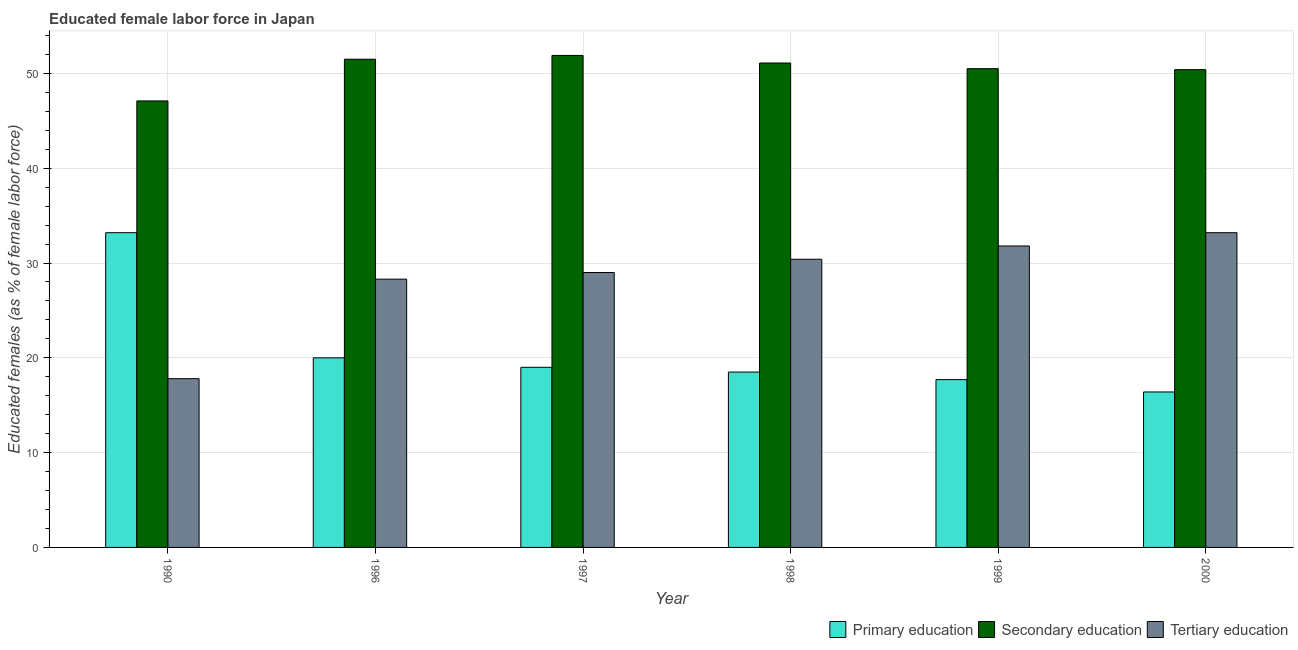How many different coloured bars are there?
Make the answer very short. 3. How many groups of bars are there?
Offer a very short reply. 6. Are the number of bars per tick equal to the number of legend labels?
Your answer should be compact. Yes. Are the number of bars on each tick of the X-axis equal?
Your answer should be very brief. Yes. How many bars are there on the 3rd tick from the right?
Your answer should be very brief. 3. What is the label of the 3rd group of bars from the left?
Give a very brief answer. 1997. What is the percentage of female labor force who received secondary education in 2000?
Your response must be concise. 50.4. Across all years, what is the maximum percentage of female labor force who received primary education?
Ensure brevity in your answer.  33.2. Across all years, what is the minimum percentage of female labor force who received tertiary education?
Keep it short and to the point. 17.8. In which year was the percentage of female labor force who received primary education minimum?
Provide a short and direct response. 2000. What is the total percentage of female labor force who received tertiary education in the graph?
Make the answer very short. 170.5. What is the difference between the percentage of female labor force who received secondary education in 1999 and that in 2000?
Your answer should be very brief. 0.1. What is the difference between the percentage of female labor force who received tertiary education in 2000 and the percentage of female labor force who received secondary education in 1996?
Offer a terse response. 4.9. What is the average percentage of female labor force who received tertiary education per year?
Your answer should be compact. 28.42. In how many years, is the percentage of female labor force who received tertiary education greater than 22 %?
Your answer should be very brief. 5. What is the ratio of the percentage of female labor force who received primary education in 1990 to that in 1996?
Offer a terse response. 1.66. Is the difference between the percentage of female labor force who received tertiary education in 1990 and 1996 greater than the difference between the percentage of female labor force who received primary education in 1990 and 1996?
Provide a succinct answer. No. What is the difference between the highest and the second highest percentage of female labor force who received tertiary education?
Make the answer very short. 1.4. What is the difference between the highest and the lowest percentage of female labor force who received secondary education?
Make the answer very short. 4.8. What does the 3rd bar from the right in 1996 represents?
Provide a short and direct response. Primary education. How many bars are there?
Provide a succinct answer. 18. How many years are there in the graph?
Offer a terse response. 6. Are the values on the major ticks of Y-axis written in scientific E-notation?
Keep it short and to the point. No. Does the graph contain any zero values?
Offer a terse response. No. How are the legend labels stacked?
Keep it short and to the point. Horizontal. What is the title of the graph?
Keep it short and to the point. Educated female labor force in Japan. What is the label or title of the X-axis?
Offer a terse response. Year. What is the label or title of the Y-axis?
Provide a succinct answer. Educated females (as % of female labor force). What is the Educated females (as % of female labor force) of Primary education in 1990?
Make the answer very short. 33.2. What is the Educated females (as % of female labor force) of Secondary education in 1990?
Offer a terse response. 47.1. What is the Educated females (as % of female labor force) of Tertiary education in 1990?
Your response must be concise. 17.8. What is the Educated females (as % of female labor force) in Primary education in 1996?
Ensure brevity in your answer.  20. What is the Educated females (as % of female labor force) in Secondary education in 1996?
Your answer should be compact. 51.5. What is the Educated females (as % of female labor force) in Tertiary education in 1996?
Provide a short and direct response. 28.3. What is the Educated females (as % of female labor force) of Secondary education in 1997?
Offer a very short reply. 51.9. What is the Educated females (as % of female labor force) of Tertiary education in 1997?
Offer a very short reply. 29. What is the Educated females (as % of female labor force) of Secondary education in 1998?
Offer a terse response. 51.1. What is the Educated females (as % of female labor force) of Tertiary education in 1998?
Your answer should be very brief. 30.4. What is the Educated females (as % of female labor force) of Primary education in 1999?
Offer a terse response. 17.7. What is the Educated females (as % of female labor force) in Secondary education in 1999?
Provide a succinct answer. 50.5. What is the Educated females (as % of female labor force) in Tertiary education in 1999?
Your answer should be very brief. 31.8. What is the Educated females (as % of female labor force) in Primary education in 2000?
Make the answer very short. 16.4. What is the Educated females (as % of female labor force) in Secondary education in 2000?
Keep it short and to the point. 50.4. What is the Educated females (as % of female labor force) of Tertiary education in 2000?
Keep it short and to the point. 33.2. Across all years, what is the maximum Educated females (as % of female labor force) of Primary education?
Offer a terse response. 33.2. Across all years, what is the maximum Educated females (as % of female labor force) of Secondary education?
Offer a very short reply. 51.9. Across all years, what is the maximum Educated females (as % of female labor force) in Tertiary education?
Provide a succinct answer. 33.2. Across all years, what is the minimum Educated females (as % of female labor force) of Primary education?
Offer a very short reply. 16.4. Across all years, what is the minimum Educated females (as % of female labor force) in Secondary education?
Provide a short and direct response. 47.1. Across all years, what is the minimum Educated females (as % of female labor force) of Tertiary education?
Make the answer very short. 17.8. What is the total Educated females (as % of female labor force) in Primary education in the graph?
Offer a very short reply. 124.8. What is the total Educated females (as % of female labor force) of Secondary education in the graph?
Your answer should be compact. 302.5. What is the total Educated females (as % of female labor force) of Tertiary education in the graph?
Give a very brief answer. 170.5. What is the difference between the Educated females (as % of female labor force) in Tertiary education in 1990 and that in 1996?
Provide a short and direct response. -10.5. What is the difference between the Educated females (as % of female labor force) of Secondary education in 1990 and that in 1997?
Make the answer very short. -4.8. What is the difference between the Educated females (as % of female labor force) of Tertiary education in 1990 and that in 1997?
Keep it short and to the point. -11.2. What is the difference between the Educated females (as % of female labor force) of Tertiary education in 1990 and that in 1998?
Your answer should be compact. -12.6. What is the difference between the Educated females (as % of female labor force) of Primary education in 1990 and that in 1999?
Your response must be concise. 15.5. What is the difference between the Educated females (as % of female labor force) of Tertiary education in 1990 and that in 1999?
Make the answer very short. -14. What is the difference between the Educated females (as % of female labor force) of Secondary education in 1990 and that in 2000?
Keep it short and to the point. -3.3. What is the difference between the Educated females (as % of female labor force) in Tertiary education in 1990 and that in 2000?
Give a very brief answer. -15.4. What is the difference between the Educated females (as % of female labor force) of Primary education in 1996 and that in 1997?
Provide a succinct answer. 1. What is the difference between the Educated females (as % of female labor force) in Secondary education in 1996 and that in 1997?
Provide a succinct answer. -0.4. What is the difference between the Educated females (as % of female labor force) in Tertiary education in 1996 and that in 1997?
Give a very brief answer. -0.7. What is the difference between the Educated females (as % of female labor force) in Primary education in 1996 and that in 1998?
Ensure brevity in your answer.  1.5. What is the difference between the Educated females (as % of female labor force) in Primary education in 1996 and that in 1999?
Ensure brevity in your answer.  2.3. What is the difference between the Educated females (as % of female labor force) of Secondary education in 1996 and that in 1999?
Give a very brief answer. 1. What is the difference between the Educated females (as % of female labor force) in Tertiary education in 1996 and that in 1999?
Keep it short and to the point. -3.5. What is the difference between the Educated females (as % of female labor force) in Primary education in 1997 and that in 1998?
Make the answer very short. 0.5. What is the difference between the Educated females (as % of female labor force) in Secondary education in 1997 and that in 1998?
Offer a very short reply. 0.8. What is the difference between the Educated females (as % of female labor force) of Primary education in 1997 and that in 1999?
Ensure brevity in your answer.  1.3. What is the difference between the Educated females (as % of female labor force) of Secondary education in 1997 and that in 1999?
Your response must be concise. 1.4. What is the difference between the Educated females (as % of female labor force) in Tertiary education in 1997 and that in 1999?
Your answer should be compact. -2.8. What is the difference between the Educated females (as % of female labor force) of Secondary education in 1997 and that in 2000?
Make the answer very short. 1.5. What is the difference between the Educated females (as % of female labor force) of Tertiary education in 1997 and that in 2000?
Keep it short and to the point. -4.2. What is the difference between the Educated females (as % of female labor force) in Secondary education in 1998 and that in 1999?
Your answer should be compact. 0.6. What is the difference between the Educated females (as % of female labor force) of Tertiary education in 1998 and that in 1999?
Provide a succinct answer. -1.4. What is the difference between the Educated females (as % of female labor force) of Primary education in 1998 and that in 2000?
Ensure brevity in your answer.  2.1. What is the difference between the Educated females (as % of female labor force) in Secondary education in 1998 and that in 2000?
Your response must be concise. 0.7. What is the difference between the Educated females (as % of female labor force) in Secondary education in 1999 and that in 2000?
Make the answer very short. 0.1. What is the difference between the Educated females (as % of female labor force) of Primary education in 1990 and the Educated females (as % of female labor force) of Secondary education in 1996?
Offer a terse response. -18.3. What is the difference between the Educated females (as % of female labor force) of Primary education in 1990 and the Educated females (as % of female labor force) of Secondary education in 1997?
Give a very brief answer. -18.7. What is the difference between the Educated females (as % of female labor force) in Secondary education in 1990 and the Educated females (as % of female labor force) in Tertiary education in 1997?
Your answer should be compact. 18.1. What is the difference between the Educated females (as % of female labor force) in Primary education in 1990 and the Educated females (as % of female labor force) in Secondary education in 1998?
Provide a short and direct response. -17.9. What is the difference between the Educated females (as % of female labor force) in Primary education in 1990 and the Educated females (as % of female labor force) in Secondary education in 1999?
Make the answer very short. -17.3. What is the difference between the Educated females (as % of female labor force) in Primary education in 1990 and the Educated females (as % of female labor force) in Tertiary education in 1999?
Provide a short and direct response. 1.4. What is the difference between the Educated females (as % of female labor force) of Primary education in 1990 and the Educated females (as % of female labor force) of Secondary education in 2000?
Your answer should be compact. -17.2. What is the difference between the Educated females (as % of female labor force) of Primary education in 1996 and the Educated females (as % of female labor force) of Secondary education in 1997?
Offer a terse response. -31.9. What is the difference between the Educated females (as % of female labor force) in Primary education in 1996 and the Educated females (as % of female labor force) in Tertiary education in 1997?
Keep it short and to the point. -9. What is the difference between the Educated females (as % of female labor force) of Primary education in 1996 and the Educated females (as % of female labor force) of Secondary education in 1998?
Your answer should be compact. -31.1. What is the difference between the Educated females (as % of female labor force) of Primary education in 1996 and the Educated females (as % of female labor force) of Tertiary education in 1998?
Your answer should be compact. -10.4. What is the difference between the Educated females (as % of female labor force) in Secondary education in 1996 and the Educated females (as % of female labor force) in Tertiary education in 1998?
Provide a short and direct response. 21.1. What is the difference between the Educated females (as % of female labor force) of Primary education in 1996 and the Educated females (as % of female labor force) of Secondary education in 1999?
Offer a very short reply. -30.5. What is the difference between the Educated females (as % of female labor force) in Primary education in 1996 and the Educated females (as % of female labor force) in Tertiary education in 1999?
Provide a succinct answer. -11.8. What is the difference between the Educated females (as % of female labor force) in Secondary education in 1996 and the Educated females (as % of female labor force) in Tertiary education in 1999?
Provide a short and direct response. 19.7. What is the difference between the Educated females (as % of female labor force) in Primary education in 1996 and the Educated females (as % of female labor force) in Secondary education in 2000?
Your answer should be compact. -30.4. What is the difference between the Educated females (as % of female labor force) in Primary education in 1997 and the Educated females (as % of female labor force) in Secondary education in 1998?
Ensure brevity in your answer.  -32.1. What is the difference between the Educated females (as % of female labor force) of Primary education in 1997 and the Educated females (as % of female labor force) of Tertiary education in 1998?
Your answer should be very brief. -11.4. What is the difference between the Educated females (as % of female labor force) of Primary education in 1997 and the Educated females (as % of female labor force) of Secondary education in 1999?
Offer a very short reply. -31.5. What is the difference between the Educated females (as % of female labor force) in Primary education in 1997 and the Educated females (as % of female labor force) in Tertiary education in 1999?
Provide a short and direct response. -12.8. What is the difference between the Educated females (as % of female labor force) in Secondary education in 1997 and the Educated females (as % of female labor force) in Tertiary education in 1999?
Your response must be concise. 20.1. What is the difference between the Educated females (as % of female labor force) in Primary education in 1997 and the Educated females (as % of female labor force) in Secondary education in 2000?
Your answer should be very brief. -31.4. What is the difference between the Educated females (as % of female labor force) in Primary education in 1998 and the Educated females (as % of female labor force) in Secondary education in 1999?
Keep it short and to the point. -32. What is the difference between the Educated females (as % of female labor force) in Primary education in 1998 and the Educated females (as % of female labor force) in Tertiary education in 1999?
Your answer should be very brief. -13.3. What is the difference between the Educated females (as % of female labor force) in Secondary education in 1998 and the Educated females (as % of female labor force) in Tertiary education in 1999?
Keep it short and to the point. 19.3. What is the difference between the Educated females (as % of female labor force) of Primary education in 1998 and the Educated females (as % of female labor force) of Secondary education in 2000?
Your answer should be very brief. -31.9. What is the difference between the Educated females (as % of female labor force) of Primary education in 1998 and the Educated females (as % of female labor force) of Tertiary education in 2000?
Provide a short and direct response. -14.7. What is the difference between the Educated females (as % of female labor force) of Secondary education in 1998 and the Educated females (as % of female labor force) of Tertiary education in 2000?
Offer a terse response. 17.9. What is the difference between the Educated females (as % of female labor force) in Primary education in 1999 and the Educated females (as % of female labor force) in Secondary education in 2000?
Keep it short and to the point. -32.7. What is the difference between the Educated females (as % of female labor force) of Primary education in 1999 and the Educated females (as % of female labor force) of Tertiary education in 2000?
Ensure brevity in your answer.  -15.5. What is the average Educated females (as % of female labor force) of Primary education per year?
Make the answer very short. 20.8. What is the average Educated females (as % of female labor force) of Secondary education per year?
Your answer should be very brief. 50.42. What is the average Educated females (as % of female labor force) in Tertiary education per year?
Make the answer very short. 28.42. In the year 1990, what is the difference between the Educated females (as % of female labor force) of Primary education and Educated females (as % of female labor force) of Secondary education?
Give a very brief answer. -13.9. In the year 1990, what is the difference between the Educated females (as % of female labor force) of Primary education and Educated females (as % of female labor force) of Tertiary education?
Ensure brevity in your answer.  15.4. In the year 1990, what is the difference between the Educated females (as % of female labor force) of Secondary education and Educated females (as % of female labor force) of Tertiary education?
Make the answer very short. 29.3. In the year 1996, what is the difference between the Educated females (as % of female labor force) in Primary education and Educated females (as % of female labor force) in Secondary education?
Your response must be concise. -31.5. In the year 1996, what is the difference between the Educated females (as % of female labor force) in Secondary education and Educated females (as % of female labor force) in Tertiary education?
Give a very brief answer. 23.2. In the year 1997, what is the difference between the Educated females (as % of female labor force) in Primary education and Educated females (as % of female labor force) in Secondary education?
Offer a terse response. -32.9. In the year 1997, what is the difference between the Educated females (as % of female labor force) in Primary education and Educated females (as % of female labor force) in Tertiary education?
Make the answer very short. -10. In the year 1997, what is the difference between the Educated females (as % of female labor force) in Secondary education and Educated females (as % of female labor force) in Tertiary education?
Your answer should be very brief. 22.9. In the year 1998, what is the difference between the Educated females (as % of female labor force) of Primary education and Educated females (as % of female labor force) of Secondary education?
Make the answer very short. -32.6. In the year 1998, what is the difference between the Educated females (as % of female labor force) of Primary education and Educated females (as % of female labor force) of Tertiary education?
Ensure brevity in your answer.  -11.9. In the year 1998, what is the difference between the Educated females (as % of female labor force) in Secondary education and Educated females (as % of female labor force) in Tertiary education?
Your answer should be very brief. 20.7. In the year 1999, what is the difference between the Educated females (as % of female labor force) in Primary education and Educated females (as % of female labor force) in Secondary education?
Offer a very short reply. -32.8. In the year 1999, what is the difference between the Educated females (as % of female labor force) of Primary education and Educated females (as % of female labor force) of Tertiary education?
Offer a terse response. -14.1. In the year 1999, what is the difference between the Educated females (as % of female labor force) of Secondary education and Educated females (as % of female labor force) of Tertiary education?
Your response must be concise. 18.7. In the year 2000, what is the difference between the Educated females (as % of female labor force) in Primary education and Educated females (as % of female labor force) in Secondary education?
Give a very brief answer. -34. In the year 2000, what is the difference between the Educated females (as % of female labor force) of Primary education and Educated females (as % of female labor force) of Tertiary education?
Offer a very short reply. -16.8. What is the ratio of the Educated females (as % of female labor force) in Primary education in 1990 to that in 1996?
Provide a succinct answer. 1.66. What is the ratio of the Educated females (as % of female labor force) in Secondary education in 1990 to that in 1996?
Your response must be concise. 0.91. What is the ratio of the Educated females (as % of female labor force) in Tertiary education in 1990 to that in 1996?
Your answer should be very brief. 0.63. What is the ratio of the Educated females (as % of female labor force) in Primary education in 1990 to that in 1997?
Offer a terse response. 1.75. What is the ratio of the Educated females (as % of female labor force) in Secondary education in 1990 to that in 1997?
Offer a terse response. 0.91. What is the ratio of the Educated females (as % of female labor force) in Tertiary education in 1990 to that in 1997?
Offer a terse response. 0.61. What is the ratio of the Educated females (as % of female labor force) of Primary education in 1990 to that in 1998?
Give a very brief answer. 1.79. What is the ratio of the Educated females (as % of female labor force) of Secondary education in 1990 to that in 1998?
Provide a short and direct response. 0.92. What is the ratio of the Educated females (as % of female labor force) of Tertiary education in 1990 to that in 1998?
Offer a very short reply. 0.59. What is the ratio of the Educated females (as % of female labor force) in Primary education in 1990 to that in 1999?
Ensure brevity in your answer.  1.88. What is the ratio of the Educated females (as % of female labor force) in Secondary education in 1990 to that in 1999?
Offer a very short reply. 0.93. What is the ratio of the Educated females (as % of female labor force) of Tertiary education in 1990 to that in 1999?
Offer a very short reply. 0.56. What is the ratio of the Educated females (as % of female labor force) in Primary education in 1990 to that in 2000?
Ensure brevity in your answer.  2.02. What is the ratio of the Educated females (as % of female labor force) in Secondary education in 1990 to that in 2000?
Ensure brevity in your answer.  0.93. What is the ratio of the Educated females (as % of female labor force) in Tertiary education in 1990 to that in 2000?
Your answer should be compact. 0.54. What is the ratio of the Educated females (as % of female labor force) of Primary education in 1996 to that in 1997?
Make the answer very short. 1.05. What is the ratio of the Educated females (as % of female labor force) in Tertiary education in 1996 to that in 1997?
Offer a very short reply. 0.98. What is the ratio of the Educated females (as % of female labor force) of Primary education in 1996 to that in 1998?
Your response must be concise. 1.08. What is the ratio of the Educated females (as % of female labor force) in Tertiary education in 1996 to that in 1998?
Your response must be concise. 0.93. What is the ratio of the Educated females (as % of female labor force) in Primary education in 1996 to that in 1999?
Give a very brief answer. 1.13. What is the ratio of the Educated females (as % of female labor force) in Secondary education in 1996 to that in 1999?
Provide a short and direct response. 1.02. What is the ratio of the Educated females (as % of female labor force) in Tertiary education in 1996 to that in 1999?
Keep it short and to the point. 0.89. What is the ratio of the Educated females (as % of female labor force) of Primary education in 1996 to that in 2000?
Make the answer very short. 1.22. What is the ratio of the Educated females (as % of female labor force) in Secondary education in 1996 to that in 2000?
Your answer should be compact. 1.02. What is the ratio of the Educated females (as % of female labor force) in Tertiary education in 1996 to that in 2000?
Ensure brevity in your answer.  0.85. What is the ratio of the Educated females (as % of female labor force) in Secondary education in 1997 to that in 1998?
Your answer should be very brief. 1.02. What is the ratio of the Educated females (as % of female labor force) of Tertiary education in 1997 to that in 1998?
Your answer should be compact. 0.95. What is the ratio of the Educated females (as % of female labor force) of Primary education in 1997 to that in 1999?
Offer a terse response. 1.07. What is the ratio of the Educated females (as % of female labor force) of Secondary education in 1997 to that in 1999?
Provide a succinct answer. 1.03. What is the ratio of the Educated females (as % of female labor force) in Tertiary education in 1997 to that in 1999?
Offer a terse response. 0.91. What is the ratio of the Educated females (as % of female labor force) in Primary education in 1997 to that in 2000?
Ensure brevity in your answer.  1.16. What is the ratio of the Educated females (as % of female labor force) in Secondary education in 1997 to that in 2000?
Your response must be concise. 1.03. What is the ratio of the Educated females (as % of female labor force) in Tertiary education in 1997 to that in 2000?
Your answer should be compact. 0.87. What is the ratio of the Educated females (as % of female labor force) of Primary education in 1998 to that in 1999?
Offer a terse response. 1.05. What is the ratio of the Educated females (as % of female labor force) in Secondary education in 1998 to that in 1999?
Your response must be concise. 1.01. What is the ratio of the Educated females (as % of female labor force) in Tertiary education in 1998 to that in 1999?
Provide a succinct answer. 0.96. What is the ratio of the Educated females (as % of female labor force) in Primary education in 1998 to that in 2000?
Your response must be concise. 1.13. What is the ratio of the Educated females (as % of female labor force) of Secondary education in 1998 to that in 2000?
Your response must be concise. 1.01. What is the ratio of the Educated females (as % of female labor force) of Tertiary education in 1998 to that in 2000?
Your response must be concise. 0.92. What is the ratio of the Educated females (as % of female labor force) in Primary education in 1999 to that in 2000?
Ensure brevity in your answer.  1.08. What is the ratio of the Educated females (as % of female labor force) in Tertiary education in 1999 to that in 2000?
Make the answer very short. 0.96. What is the difference between the highest and the second highest Educated females (as % of female labor force) in Secondary education?
Ensure brevity in your answer.  0.4. What is the difference between the highest and the lowest Educated females (as % of female labor force) of Primary education?
Make the answer very short. 16.8. 